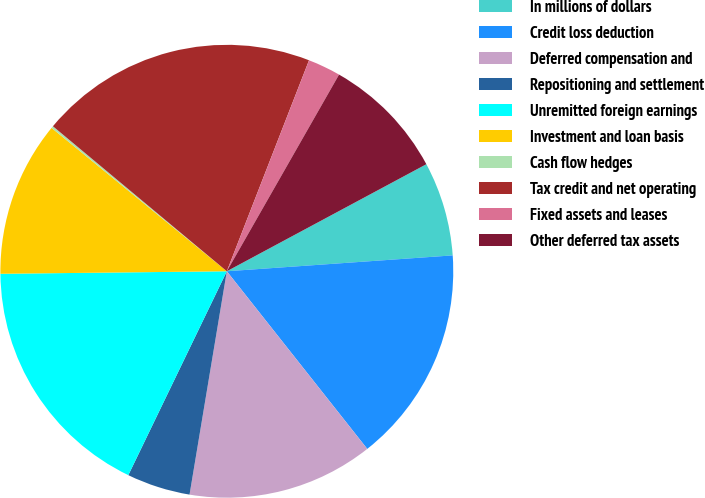Convert chart to OTSL. <chart><loc_0><loc_0><loc_500><loc_500><pie_chart><fcel>In millions of dollars<fcel>Credit loss deduction<fcel>Deferred compensation and<fcel>Repositioning and settlement<fcel>Unremitted foreign earnings<fcel>Investment and loan basis<fcel>Cash flow hedges<fcel>Tax credit and net operating<fcel>Fixed assets and leases<fcel>Other deferred tax assets<nl><fcel>6.72%<fcel>15.47%<fcel>13.28%<fcel>4.53%<fcel>17.66%<fcel>11.09%<fcel>0.15%<fcel>19.85%<fcel>2.34%<fcel>8.91%<nl></chart> 